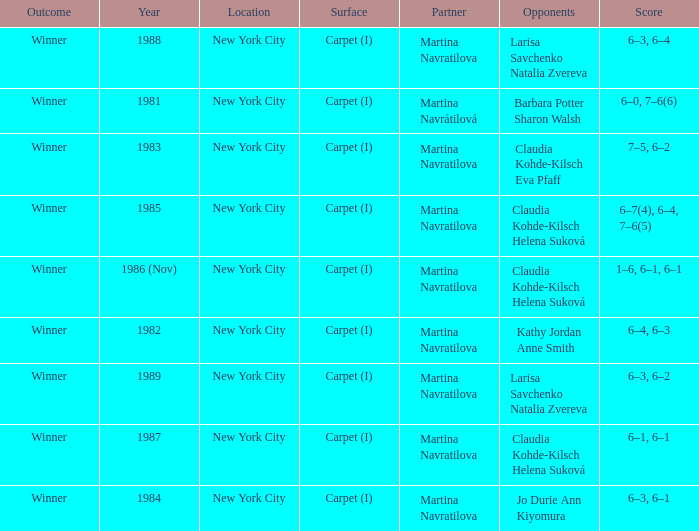How many locations hosted Claudia Kohde-Kilsch Eva Pfaff? 1.0. 